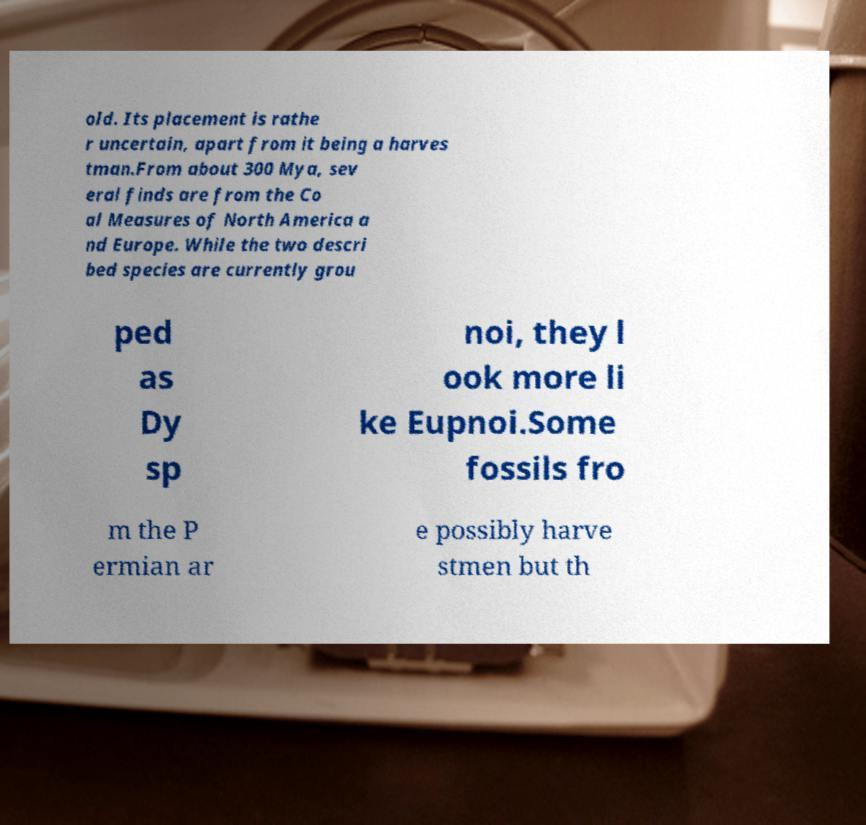Please identify and transcribe the text found in this image. old. Its placement is rathe r uncertain, apart from it being a harves tman.From about 300 Mya, sev eral finds are from the Co al Measures of North America a nd Europe. While the two descri bed species are currently grou ped as Dy sp noi, they l ook more li ke Eupnoi.Some fossils fro m the P ermian ar e possibly harve stmen but th 